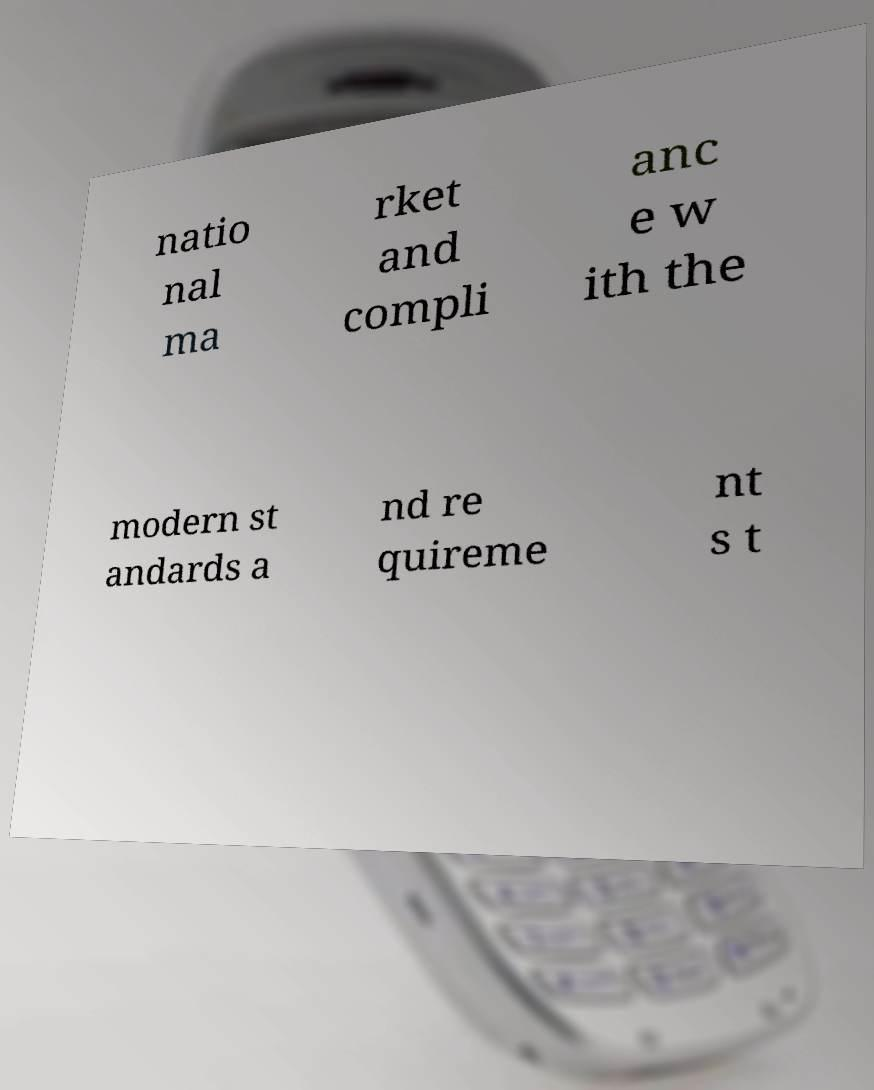Could you extract and type out the text from this image? natio nal ma rket and compli anc e w ith the modern st andards a nd re quireme nt s t 